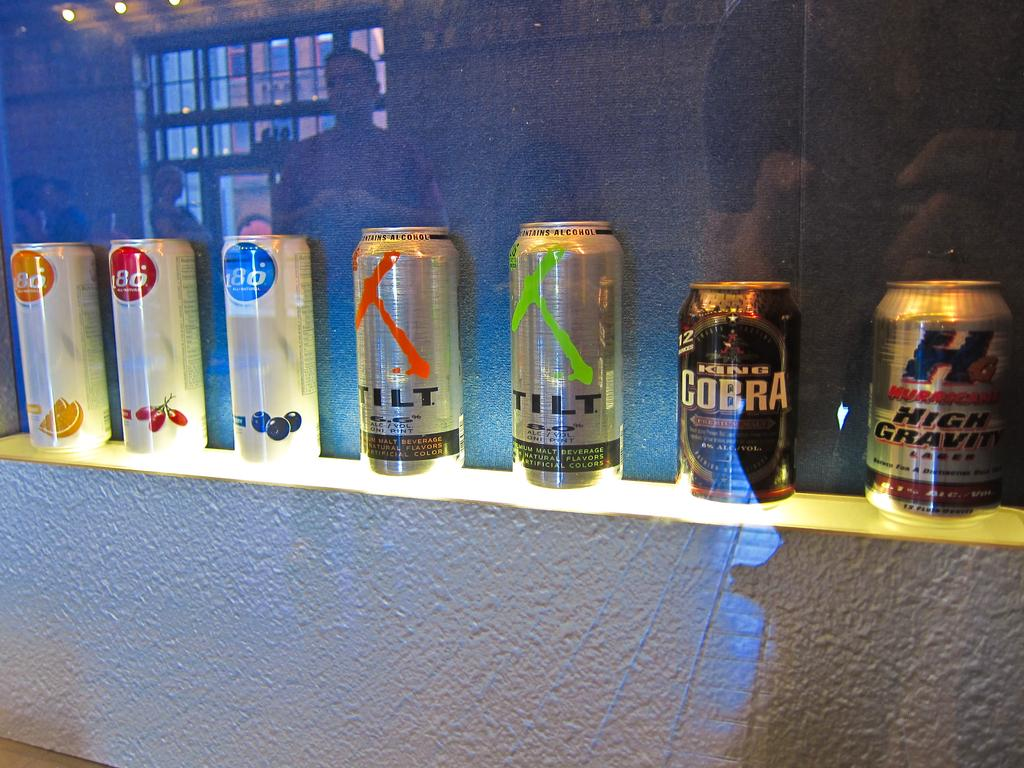Provide a one-sentence caption for the provided image. seven cans  of beer and three of them have the number 80. 